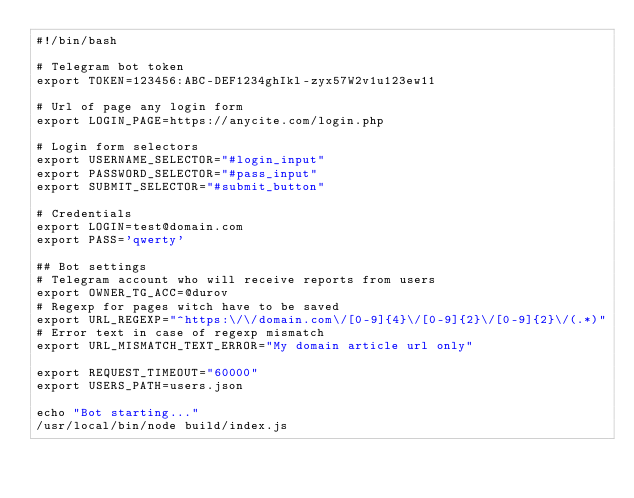Convert code to text. <code><loc_0><loc_0><loc_500><loc_500><_Bash_>#!/bin/bash

# Telegram bot token
export TOKEN=123456:ABC-DEF1234ghIkl-zyx57W2v1u123ew11

# Url of page any login form
export LOGIN_PAGE=https://anycite.com/login.php

# Login form selectors
export USERNAME_SELECTOR="#login_input"
export PASSWORD_SELECTOR="#pass_input"
export SUBMIT_SELECTOR="#submit_button"

# Credentials
export LOGIN=test@domain.com
export PASS='qwerty'

## Bot settings
# Telegram account who will receive reports from users
export OWNER_TG_ACC=@durov
# Regexp for pages witch have to be saved
export URL_REGEXP="^https:\/\/domain.com\/[0-9]{4}\/[0-9]{2}\/[0-9]{2}\/(.*)"
# Error text in case of regexp mismatch
export URL_MISMATCH_TEXT_ERROR="My domain article url only"

export REQUEST_TIMEOUT="60000"
export USERS_PATH=users.json

echo "Bot starting..."
/usr/local/bin/node build/index.js
</code> 